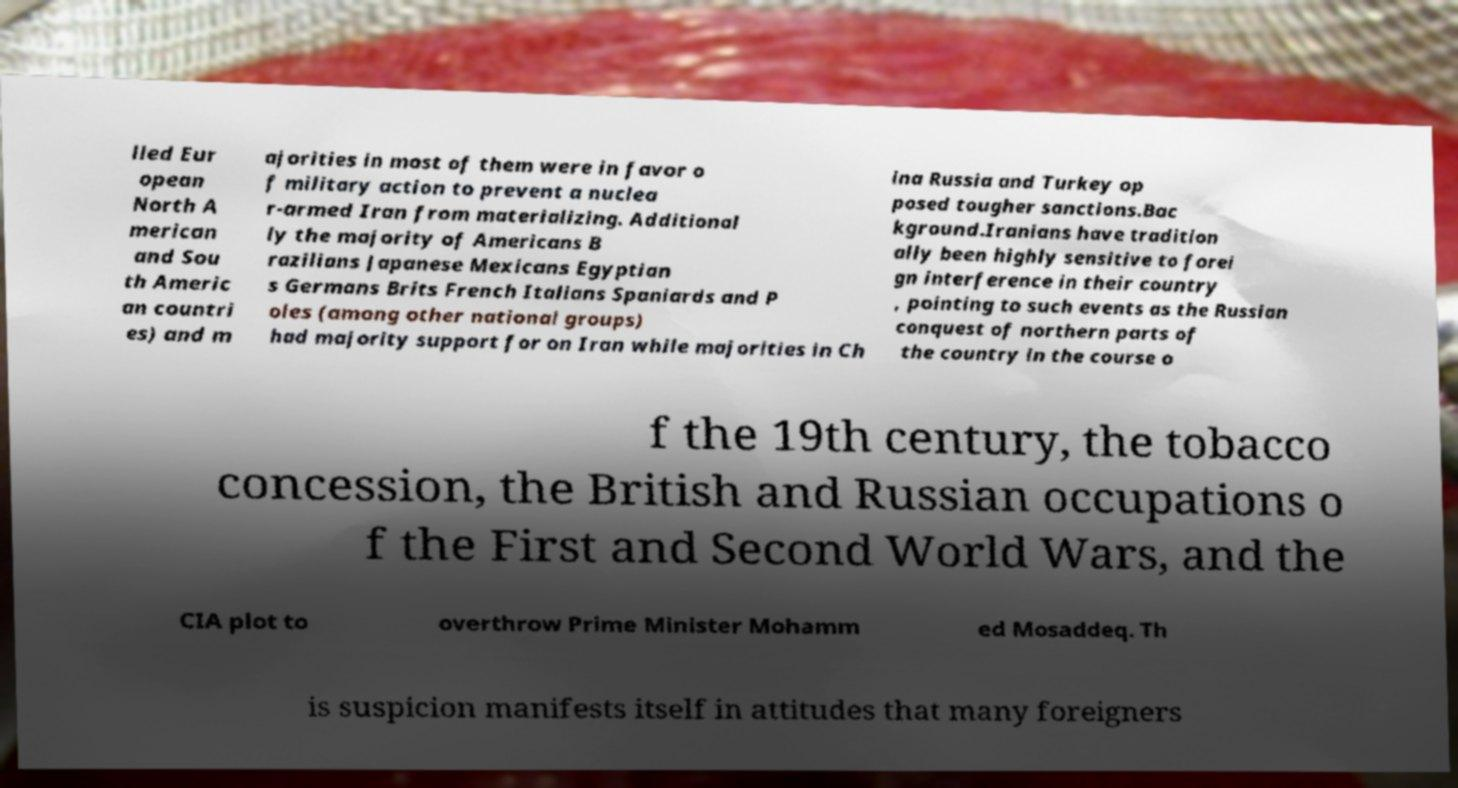Could you extract and type out the text from this image? lled Eur opean North A merican and Sou th Americ an countri es) and m ajorities in most of them were in favor o f military action to prevent a nuclea r-armed Iran from materializing. Additional ly the majority of Americans B razilians Japanese Mexicans Egyptian s Germans Brits French Italians Spaniards and P oles (among other national groups) had majority support for on Iran while majorities in Ch ina Russia and Turkey op posed tougher sanctions.Bac kground.Iranians have tradition ally been highly sensitive to forei gn interference in their country , pointing to such events as the Russian conquest of northern parts of the country in the course o f the 19th century, the tobacco concession, the British and Russian occupations o f the First and Second World Wars, and the CIA plot to overthrow Prime Minister Mohamm ed Mosaddeq. Th is suspicion manifests itself in attitudes that many foreigners 